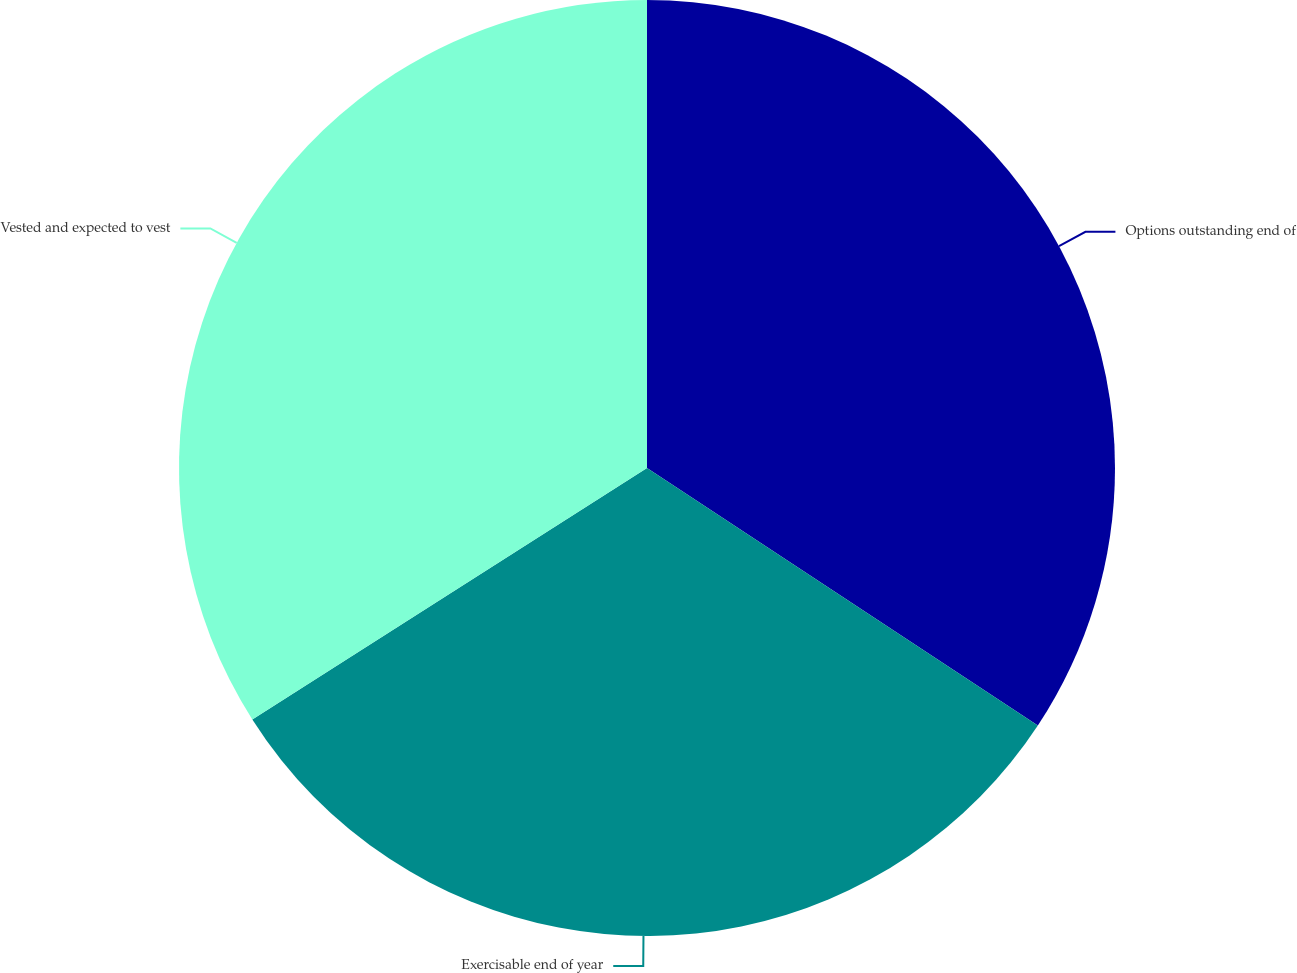Convert chart. <chart><loc_0><loc_0><loc_500><loc_500><pie_chart><fcel>Options outstanding end of<fcel>Exercisable end of year<fcel>Vested and expected to vest<nl><fcel>34.27%<fcel>31.7%<fcel>34.03%<nl></chart> 